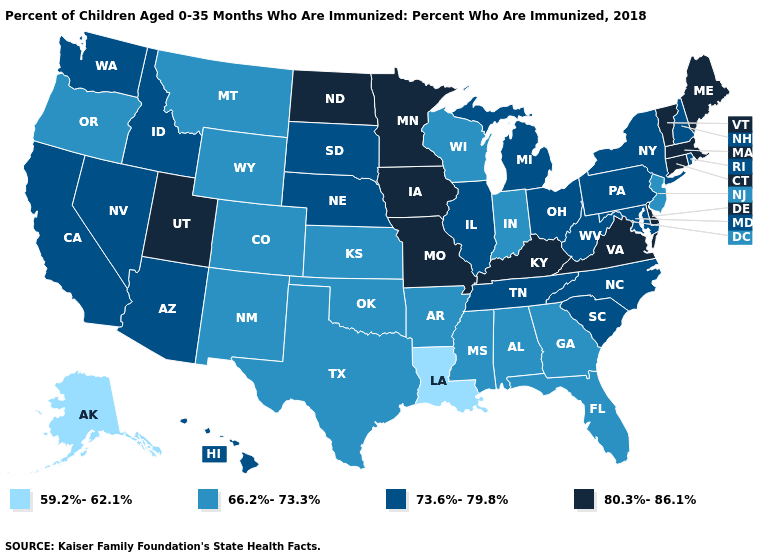Does the map have missing data?
Keep it brief. No. What is the lowest value in states that border Texas?
Be succinct. 59.2%-62.1%. Name the states that have a value in the range 80.3%-86.1%?
Concise answer only. Connecticut, Delaware, Iowa, Kentucky, Maine, Massachusetts, Minnesota, Missouri, North Dakota, Utah, Vermont, Virginia. Does Louisiana have the lowest value in the USA?
Short answer required. Yes. Among the states that border Florida , which have the lowest value?
Write a very short answer. Alabama, Georgia. What is the highest value in states that border Mississippi?
Be succinct. 73.6%-79.8%. Name the states that have a value in the range 59.2%-62.1%?
Quick response, please. Alaska, Louisiana. What is the value of Mississippi?
Keep it brief. 66.2%-73.3%. Name the states that have a value in the range 80.3%-86.1%?
Concise answer only. Connecticut, Delaware, Iowa, Kentucky, Maine, Massachusetts, Minnesota, Missouri, North Dakota, Utah, Vermont, Virginia. Name the states that have a value in the range 59.2%-62.1%?
Short answer required. Alaska, Louisiana. What is the value of Nevada?
Quick response, please. 73.6%-79.8%. Among the states that border Delaware , does Maryland have the lowest value?
Write a very short answer. No. Name the states that have a value in the range 59.2%-62.1%?
Concise answer only. Alaska, Louisiana. Which states have the highest value in the USA?
Answer briefly. Connecticut, Delaware, Iowa, Kentucky, Maine, Massachusetts, Minnesota, Missouri, North Dakota, Utah, Vermont, Virginia. How many symbols are there in the legend?
Quick response, please. 4. 